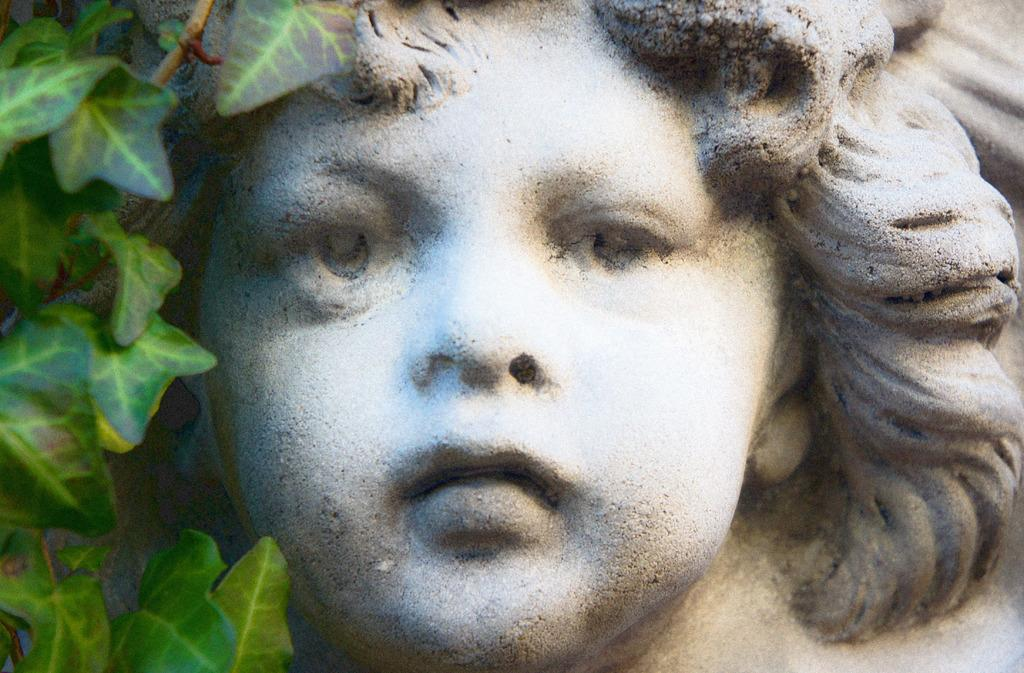What is the main subject of the image? The main subject of the image is a person statue. What colors are used for the statue? The statue is in white and black color. What type of vegetation can be seen in the image? There are green leaves in the image. What type of legal advice is the statue providing in the image? The statue is not a real person and cannot provide legal advice. Additionally, there is no indication of any legal context in the image. 